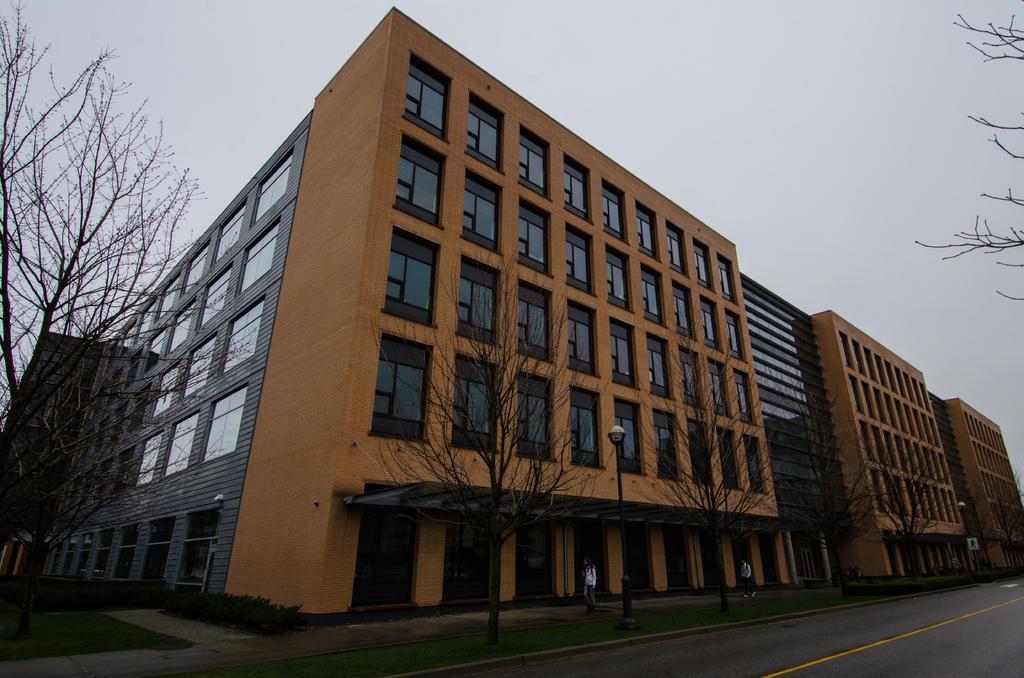Describe this image in one or two sentences. This image consists of a building in brown color. At the bottom, there is a road. In the front, we can see two persons walking on the pavement. And there are dried trees in this image. At the top, there is sky. 